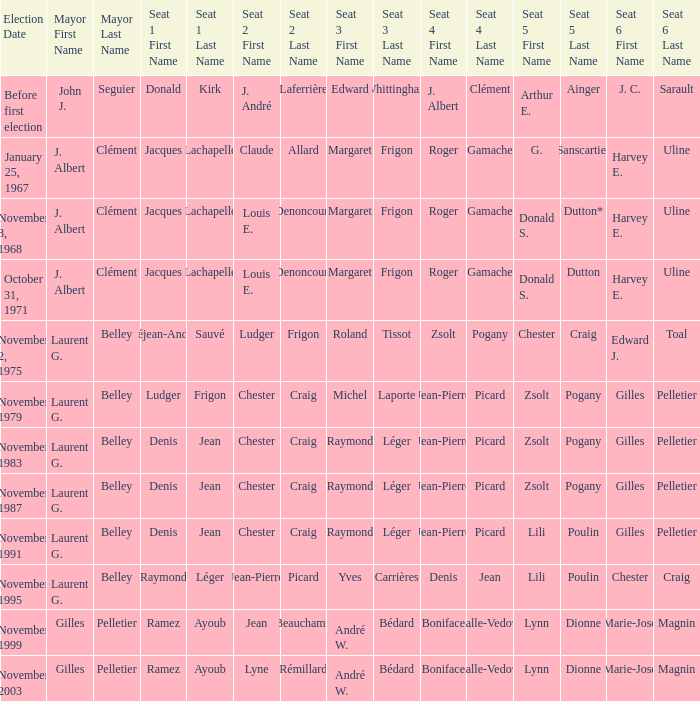Which election had seat no 1 filled by jacques lachapelle but seat no 5 was filled by g. sanscartier January 25, 1967. 